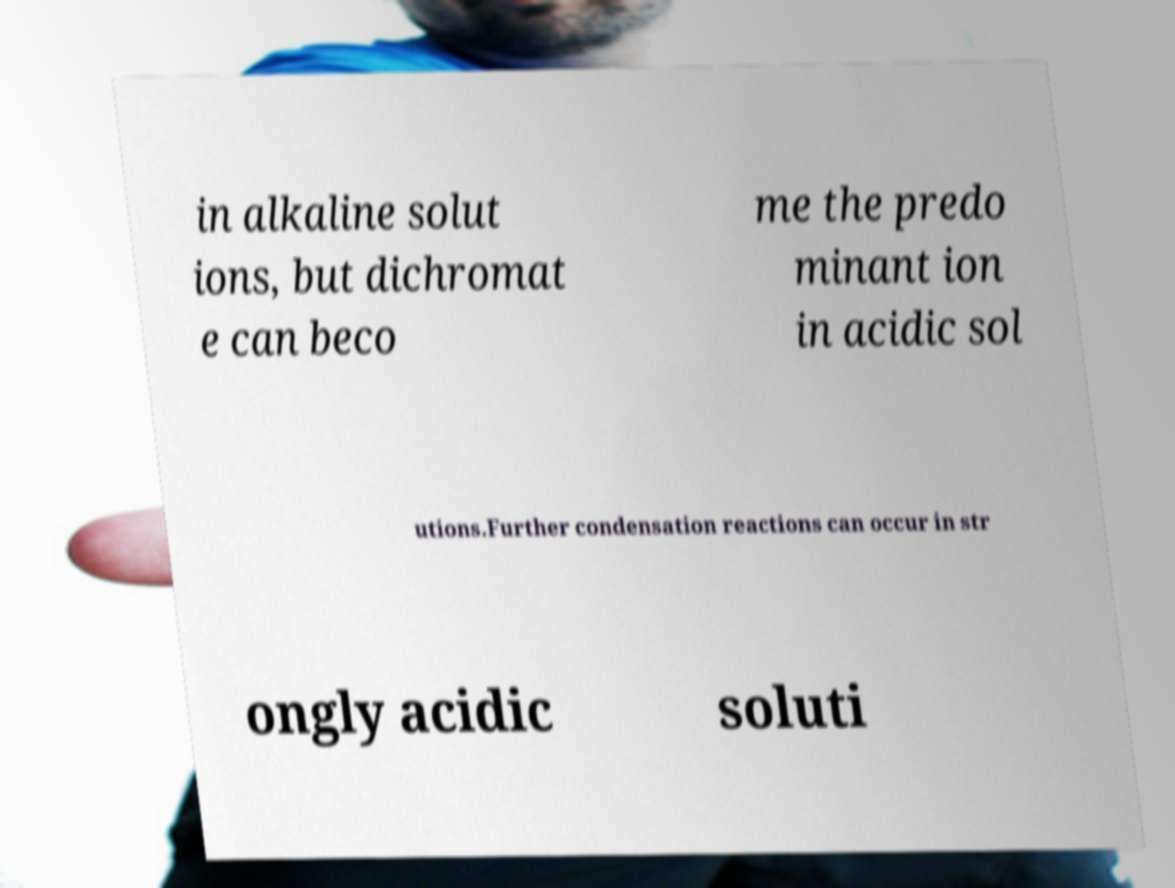I need the written content from this picture converted into text. Can you do that? in alkaline solut ions, but dichromat e can beco me the predo minant ion in acidic sol utions.Further condensation reactions can occur in str ongly acidic soluti 